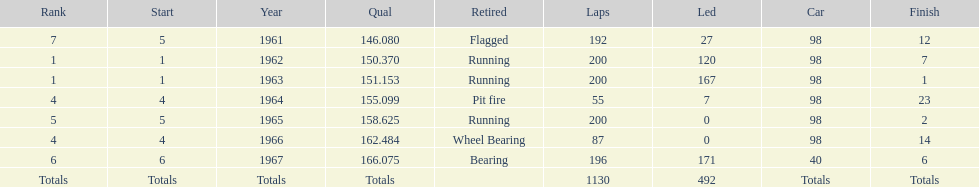What was his best finish before his first win? 7. 